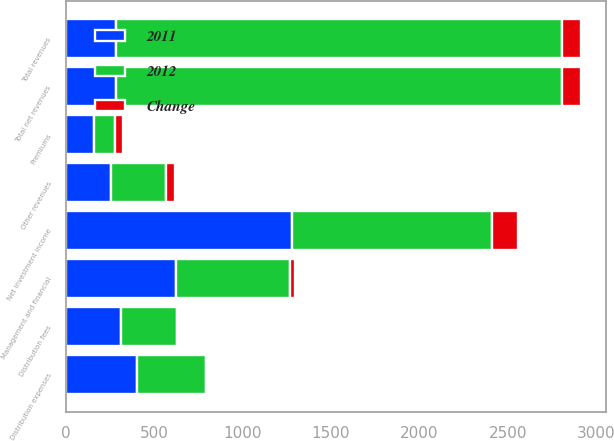Convert chart. <chart><loc_0><loc_0><loc_500><loc_500><stacked_bar_chart><ecel><fcel>Management and financial<fcel>Distribution fees<fcel>Net investment income<fcel>Premiums<fcel>Other revenues<fcel>Total revenues<fcel>Total net revenues<fcel>Distribution expenses<nl><fcel>2012<fcel>648<fcel>317<fcel>1132<fcel>118<fcel>309<fcel>2524<fcel>2524<fcel>395<nl><fcel>2011<fcel>622<fcel>312<fcel>1279<fcel>161<fcel>256<fcel>282.5<fcel>282.5<fcel>400<nl><fcel>Change<fcel>26<fcel>5<fcel>147<fcel>43<fcel>53<fcel>106<fcel>106<fcel>5<nl></chart> 